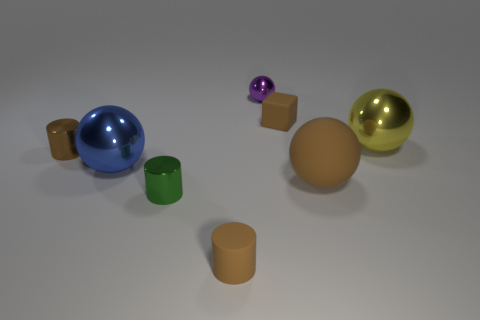How big is the cylinder that is on the right side of the tiny brown metal thing and left of the matte cylinder?
Your response must be concise. Small. Is the number of tiny brown metallic cylinders greater than the number of large red matte objects?
Keep it short and to the point. Yes. Are there any matte things that have the same color as the tiny cube?
Make the answer very short. Yes. There is a metallic thing in front of the blue thing; is its size the same as the tiny brown rubber cylinder?
Give a very brief answer. Yes. Is the number of tiny green metal cylinders less than the number of big blue blocks?
Your answer should be very brief. No. Are there any blue spheres that have the same material as the green cylinder?
Give a very brief answer. Yes. What is the shape of the tiny matte thing that is in front of the green metal cylinder?
Your answer should be compact. Cylinder. Does the tiny rubber thing that is in front of the large matte thing have the same color as the tiny block?
Provide a short and direct response. Yes. Are there fewer yellow spheres that are in front of the green object than brown matte spheres?
Give a very brief answer. Yes. There is a tiny sphere that is the same material as the yellow object; what is its color?
Your response must be concise. Purple. 